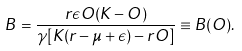<formula> <loc_0><loc_0><loc_500><loc_500>B = \frac { r \epsilon O ( K - O ) } { \gamma [ K ( r - \mu + \epsilon ) - r O ] } \equiv B ( O ) .</formula> 